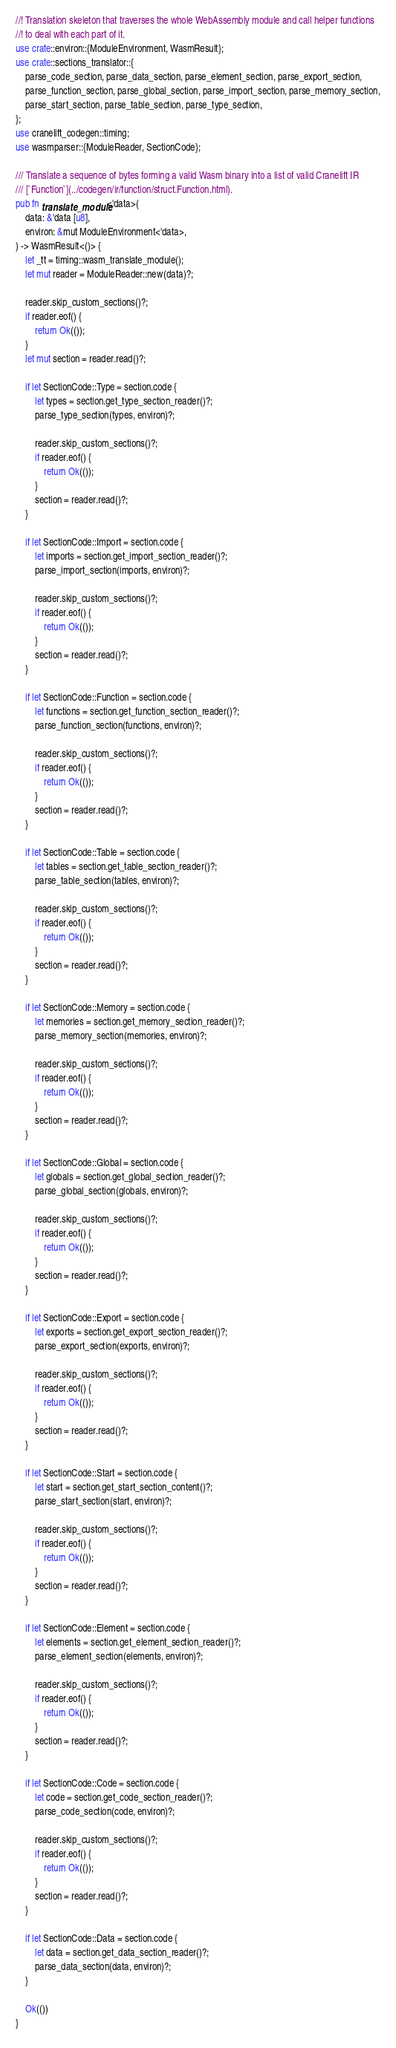Convert code to text. <code><loc_0><loc_0><loc_500><loc_500><_Rust_>//! Translation skeleton that traverses the whole WebAssembly module and call helper functions
//! to deal with each part of it.
use crate::environ::{ModuleEnvironment, WasmResult};
use crate::sections_translator::{
    parse_code_section, parse_data_section, parse_element_section, parse_export_section,
    parse_function_section, parse_global_section, parse_import_section, parse_memory_section,
    parse_start_section, parse_table_section, parse_type_section,
};
use cranelift_codegen::timing;
use wasmparser::{ModuleReader, SectionCode};

/// Translate a sequence of bytes forming a valid Wasm binary into a list of valid Cranelift IR
/// [`Function`](../codegen/ir/function/struct.Function.html).
pub fn translate_module<'data>(
    data: &'data [u8],
    environ: &mut ModuleEnvironment<'data>,
) -> WasmResult<()> {
    let _tt = timing::wasm_translate_module();
    let mut reader = ModuleReader::new(data)?;

    reader.skip_custom_sections()?;
    if reader.eof() {
        return Ok(());
    }
    let mut section = reader.read()?;

    if let SectionCode::Type = section.code {
        let types = section.get_type_section_reader()?;
        parse_type_section(types, environ)?;

        reader.skip_custom_sections()?;
        if reader.eof() {
            return Ok(());
        }
        section = reader.read()?;
    }

    if let SectionCode::Import = section.code {
        let imports = section.get_import_section_reader()?;
        parse_import_section(imports, environ)?;

        reader.skip_custom_sections()?;
        if reader.eof() {
            return Ok(());
        }
        section = reader.read()?;
    }

    if let SectionCode::Function = section.code {
        let functions = section.get_function_section_reader()?;
        parse_function_section(functions, environ)?;

        reader.skip_custom_sections()?;
        if reader.eof() {
            return Ok(());
        }
        section = reader.read()?;
    }

    if let SectionCode::Table = section.code {
        let tables = section.get_table_section_reader()?;
        parse_table_section(tables, environ)?;

        reader.skip_custom_sections()?;
        if reader.eof() {
            return Ok(());
        }
        section = reader.read()?;
    }

    if let SectionCode::Memory = section.code {
        let memories = section.get_memory_section_reader()?;
        parse_memory_section(memories, environ)?;

        reader.skip_custom_sections()?;
        if reader.eof() {
            return Ok(());
        }
        section = reader.read()?;
    }

    if let SectionCode::Global = section.code {
        let globals = section.get_global_section_reader()?;
        parse_global_section(globals, environ)?;

        reader.skip_custom_sections()?;
        if reader.eof() {
            return Ok(());
        }
        section = reader.read()?;
    }

    if let SectionCode::Export = section.code {
        let exports = section.get_export_section_reader()?;
        parse_export_section(exports, environ)?;

        reader.skip_custom_sections()?;
        if reader.eof() {
            return Ok(());
        }
        section = reader.read()?;
    }

    if let SectionCode::Start = section.code {
        let start = section.get_start_section_content()?;
        parse_start_section(start, environ)?;

        reader.skip_custom_sections()?;
        if reader.eof() {
            return Ok(());
        }
        section = reader.read()?;
    }

    if let SectionCode::Element = section.code {
        let elements = section.get_element_section_reader()?;
        parse_element_section(elements, environ)?;

        reader.skip_custom_sections()?;
        if reader.eof() {
            return Ok(());
        }
        section = reader.read()?;
    }

    if let SectionCode::Code = section.code {
        let code = section.get_code_section_reader()?;
        parse_code_section(code, environ)?;

        reader.skip_custom_sections()?;
        if reader.eof() {
            return Ok(());
        }
        section = reader.read()?;
    }

    if let SectionCode::Data = section.code {
        let data = section.get_data_section_reader()?;
        parse_data_section(data, environ)?;
    }

    Ok(())
}
</code> 